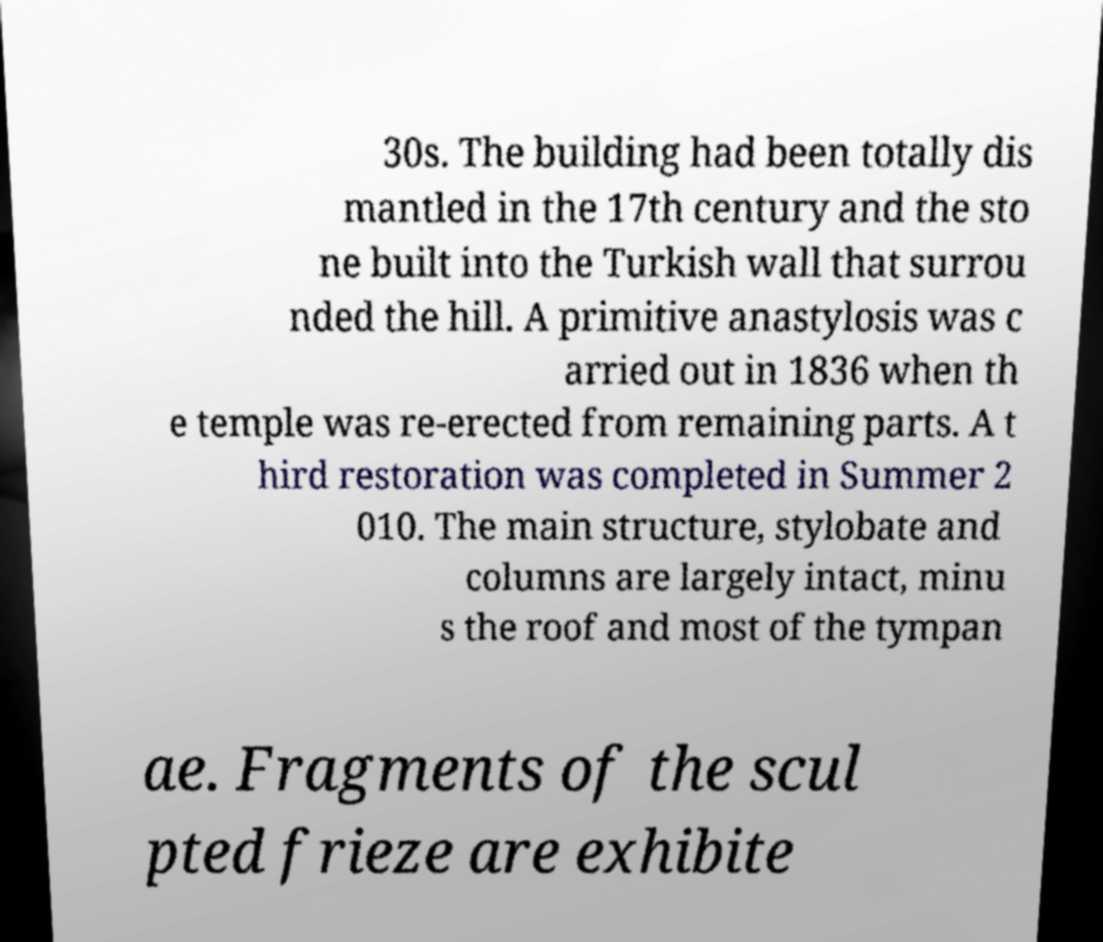There's text embedded in this image that I need extracted. Can you transcribe it verbatim? 30s. The building had been totally dis mantled in the 17th century and the sto ne built into the Turkish wall that surrou nded the hill. A primitive anastylosis was c arried out in 1836 when th e temple was re-erected from remaining parts. A t hird restoration was completed in Summer 2 010. The main structure, stylobate and columns are largely intact, minu s the roof and most of the tympan ae. Fragments of the scul pted frieze are exhibite 